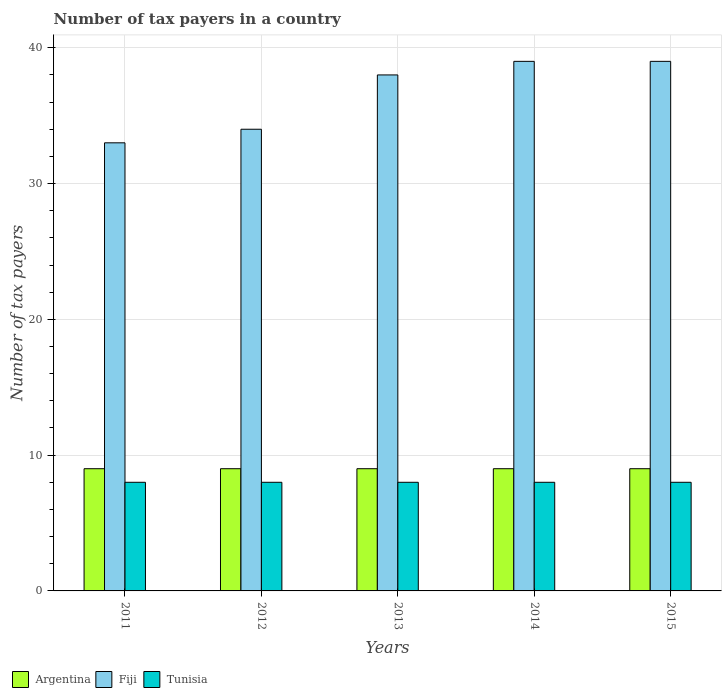How many different coloured bars are there?
Keep it short and to the point. 3. How many groups of bars are there?
Provide a short and direct response. 5. Are the number of bars per tick equal to the number of legend labels?
Make the answer very short. Yes. Are the number of bars on each tick of the X-axis equal?
Keep it short and to the point. Yes. What is the label of the 3rd group of bars from the left?
Your answer should be very brief. 2013. In how many cases, is the number of bars for a given year not equal to the number of legend labels?
Offer a very short reply. 0. What is the number of tax payers in in Argentina in 2015?
Provide a short and direct response. 9. Across all years, what is the maximum number of tax payers in in Fiji?
Provide a short and direct response. 39. Across all years, what is the minimum number of tax payers in in Argentina?
Make the answer very short. 9. In which year was the number of tax payers in in Tunisia maximum?
Offer a terse response. 2011. What is the total number of tax payers in in Fiji in the graph?
Your response must be concise. 183. What is the difference between the number of tax payers in in Argentina in 2012 and that in 2014?
Give a very brief answer. 0. What is the difference between the number of tax payers in in Tunisia in 2011 and the number of tax payers in in Argentina in 2014?
Offer a terse response. -1. In the year 2011, what is the difference between the number of tax payers in in Argentina and number of tax payers in in Fiji?
Your response must be concise. -24. In how many years, is the number of tax payers in in Argentina greater than 10?
Give a very brief answer. 0. What is the ratio of the number of tax payers in in Fiji in 2011 to that in 2015?
Make the answer very short. 0.85. Is the number of tax payers in in Fiji in 2011 less than that in 2012?
Make the answer very short. Yes. What is the difference between the highest and the second highest number of tax payers in in Tunisia?
Provide a succinct answer. 0. What is the difference between the highest and the lowest number of tax payers in in Tunisia?
Offer a terse response. 0. What does the 3rd bar from the right in 2011 represents?
Make the answer very short. Argentina. Is it the case that in every year, the sum of the number of tax payers in in Tunisia and number of tax payers in in Argentina is greater than the number of tax payers in in Fiji?
Ensure brevity in your answer.  No. How many bars are there?
Your response must be concise. 15. How many years are there in the graph?
Offer a very short reply. 5. What is the difference between two consecutive major ticks on the Y-axis?
Offer a very short reply. 10. Does the graph contain any zero values?
Make the answer very short. No. Does the graph contain grids?
Provide a succinct answer. Yes. Where does the legend appear in the graph?
Your answer should be very brief. Bottom left. How are the legend labels stacked?
Your response must be concise. Horizontal. What is the title of the graph?
Give a very brief answer. Number of tax payers in a country. What is the label or title of the Y-axis?
Provide a short and direct response. Number of tax payers. What is the Number of tax payers in Argentina in 2011?
Ensure brevity in your answer.  9. What is the Number of tax payers in Argentina in 2014?
Provide a succinct answer. 9. What is the Number of tax payers of Fiji in 2014?
Your answer should be very brief. 39. What is the Number of tax payers of Tunisia in 2014?
Offer a terse response. 8. What is the Number of tax payers in Fiji in 2015?
Offer a very short reply. 39. What is the Number of tax payers of Tunisia in 2015?
Your answer should be compact. 8. Across all years, what is the maximum Number of tax payers of Fiji?
Provide a short and direct response. 39. What is the total Number of tax payers of Argentina in the graph?
Your answer should be very brief. 45. What is the total Number of tax payers of Fiji in the graph?
Provide a succinct answer. 183. What is the difference between the Number of tax payers of Tunisia in 2011 and that in 2012?
Keep it short and to the point. 0. What is the difference between the Number of tax payers of Tunisia in 2011 and that in 2013?
Make the answer very short. 0. What is the difference between the Number of tax payers of Fiji in 2011 and that in 2014?
Provide a short and direct response. -6. What is the difference between the Number of tax payers of Argentina in 2012 and that in 2013?
Give a very brief answer. 0. What is the difference between the Number of tax payers in Fiji in 2012 and that in 2013?
Provide a short and direct response. -4. What is the difference between the Number of tax payers of Argentina in 2012 and that in 2014?
Provide a succinct answer. 0. What is the difference between the Number of tax payers in Tunisia in 2012 and that in 2014?
Your response must be concise. 0. What is the difference between the Number of tax payers in Argentina in 2012 and that in 2015?
Keep it short and to the point. 0. What is the difference between the Number of tax payers of Tunisia in 2012 and that in 2015?
Make the answer very short. 0. What is the difference between the Number of tax payers in Argentina in 2013 and that in 2014?
Make the answer very short. 0. What is the difference between the Number of tax payers in Argentina in 2013 and that in 2015?
Offer a terse response. 0. What is the difference between the Number of tax payers in Argentina in 2014 and that in 2015?
Make the answer very short. 0. What is the difference between the Number of tax payers in Argentina in 2011 and the Number of tax payers in Fiji in 2012?
Ensure brevity in your answer.  -25. What is the difference between the Number of tax payers of Argentina in 2011 and the Number of tax payers of Tunisia in 2013?
Make the answer very short. 1. What is the difference between the Number of tax payers in Argentina in 2011 and the Number of tax payers in Tunisia in 2014?
Ensure brevity in your answer.  1. What is the difference between the Number of tax payers in Argentina in 2012 and the Number of tax payers in Fiji in 2015?
Ensure brevity in your answer.  -30. What is the difference between the Number of tax payers of Fiji in 2012 and the Number of tax payers of Tunisia in 2015?
Ensure brevity in your answer.  26. What is the difference between the Number of tax payers of Argentina in 2013 and the Number of tax payers of Fiji in 2014?
Make the answer very short. -30. What is the difference between the Number of tax payers of Argentina in 2013 and the Number of tax payers of Tunisia in 2014?
Provide a succinct answer. 1. What is the difference between the Number of tax payers of Fiji in 2013 and the Number of tax payers of Tunisia in 2014?
Your answer should be compact. 30. What is the difference between the Number of tax payers of Argentina in 2013 and the Number of tax payers of Fiji in 2015?
Make the answer very short. -30. What is the difference between the Number of tax payers of Fiji in 2013 and the Number of tax payers of Tunisia in 2015?
Offer a terse response. 30. What is the difference between the Number of tax payers in Fiji in 2014 and the Number of tax payers in Tunisia in 2015?
Your answer should be compact. 31. What is the average Number of tax payers in Fiji per year?
Your answer should be very brief. 36.6. In the year 2011, what is the difference between the Number of tax payers in Argentina and Number of tax payers in Tunisia?
Your answer should be very brief. 1. In the year 2012, what is the difference between the Number of tax payers of Fiji and Number of tax payers of Tunisia?
Keep it short and to the point. 26. In the year 2013, what is the difference between the Number of tax payers in Argentina and Number of tax payers in Fiji?
Make the answer very short. -29. In the year 2014, what is the difference between the Number of tax payers of Argentina and Number of tax payers of Tunisia?
Keep it short and to the point. 1. In the year 2014, what is the difference between the Number of tax payers of Fiji and Number of tax payers of Tunisia?
Make the answer very short. 31. In the year 2015, what is the difference between the Number of tax payers in Argentina and Number of tax payers in Tunisia?
Your answer should be compact. 1. In the year 2015, what is the difference between the Number of tax payers in Fiji and Number of tax payers in Tunisia?
Offer a very short reply. 31. What is the ratio of the Number of tax payers of Fiji in 2011 to that in 2012?
Offer a terse response. 0.97. What is the ratio of the Number of tax payers in Fiji in 2011 to that in 2013?
Provide a succinct answer. 0.87. What is the ratio of the Number of tax payers in Tunisia in 2011 to that in 2013?
Ensure brevity in your answer.  1. What is the ratio of the Number of tax payers in Fiji in 2011 to that in 2014?
Offer a terse response. 0.85. What is the ratio of the Number of tax payers of Tunisia in 2011 to that in 2014?
Offer a terse response. 1. What is the ratio of the Number of tax payers in Fiji in 2011 to that in 2015?
Provide a short and direct response. 0.85. What is the ratio of the Number of tax payers of Fiji in 2012 to that in 2013?
Provide a succinct answer. 0.89. What is the ratio of the Number of tax payers of Fiji in 2012 to that in 2014?
Offer a very short reply. 0.87. What is the ratio of the Number of tax payers in Argentina in 2012 to that in 2015?
Offer a very short reply. 1. What is the ratio of the Number of tax payers in Fiji in 2012 to that in 2015?
Offer a terse response. 0.87. What is the ratio of the Number of tax payers in Fiji in 2013 to that in 2014?
Ensure brevity in your answer.  0.97. What is the ratio of the Number of tax payers of Argentina in 2013 to that in 2015?
Your response must be concise. 1. What is the ratio of the Number of tax payers of Fiji in 2013 to that in 2015?
Ensure brevity in your answer.  0.97. What is the ratio of the Number of tax payers of Tunisia in 2013 to that in 2015?
Provide a succinct answer. 1. What is the ratio of the Number of tax payers in Fiji in 2014 to that in 2015?
Make the answer very short. 1. 